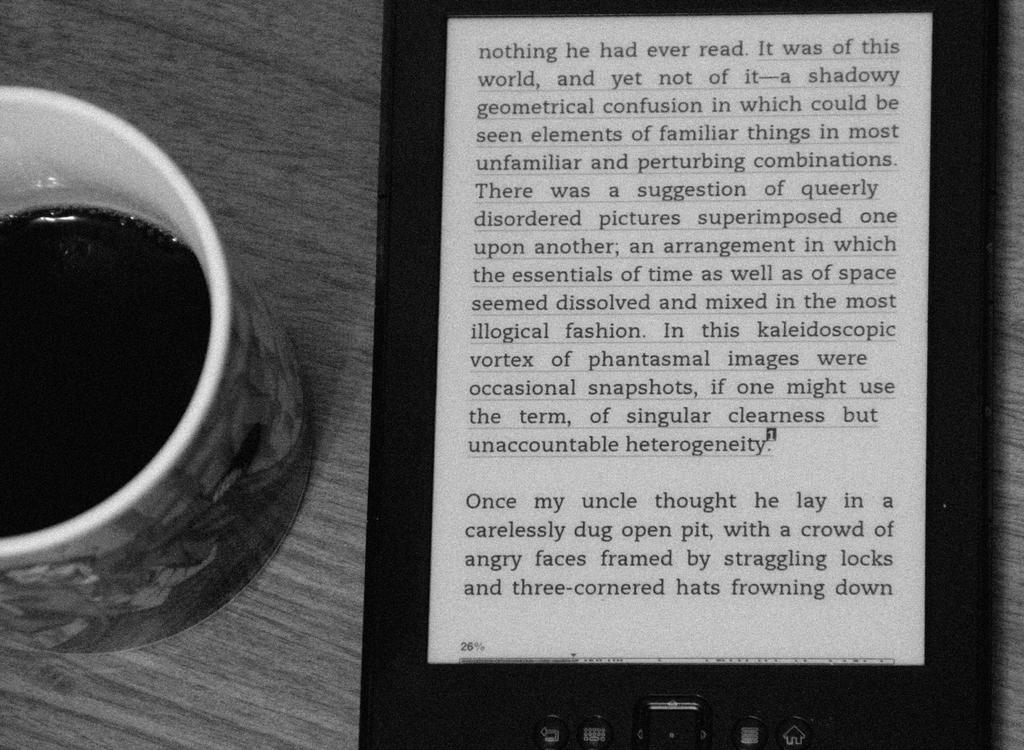<image>
Describe the image concisely. A kindle has a page that starts with Nothing open next to a cup of coffee. 